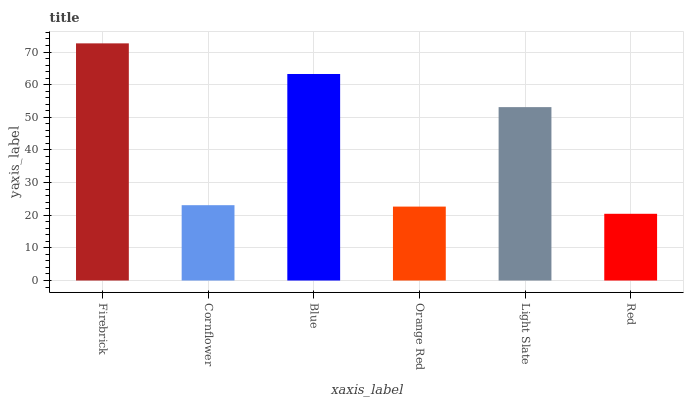Is Red the minimum?
Answer yes or no. Yes. Is Firebrick the maximum?
Answer yes or no. Yes. Is Cornflower the minimum?
Answer yes or no. No. Is Cornflower the maximum?
Answer yes or no. No. Is Firebrick greater than Cornflower?
Answer yes or no. Yes. Is Cornflower less than Firebrick?
Answer yes or no. Yes. Is Cornflower greater than Firebrick?
Answer yes or no. No. Is Firebrick less than Cornflower?
Answer yes or no. No. Is Light Slate the high median?
Answer yes or no. Yes. Is Cornflower the low median?
Answer yes or no. Yes. Is Firebrick the high median?
Answer yes or no. No. Is Blue the low median?
Answer yes or no. No. 